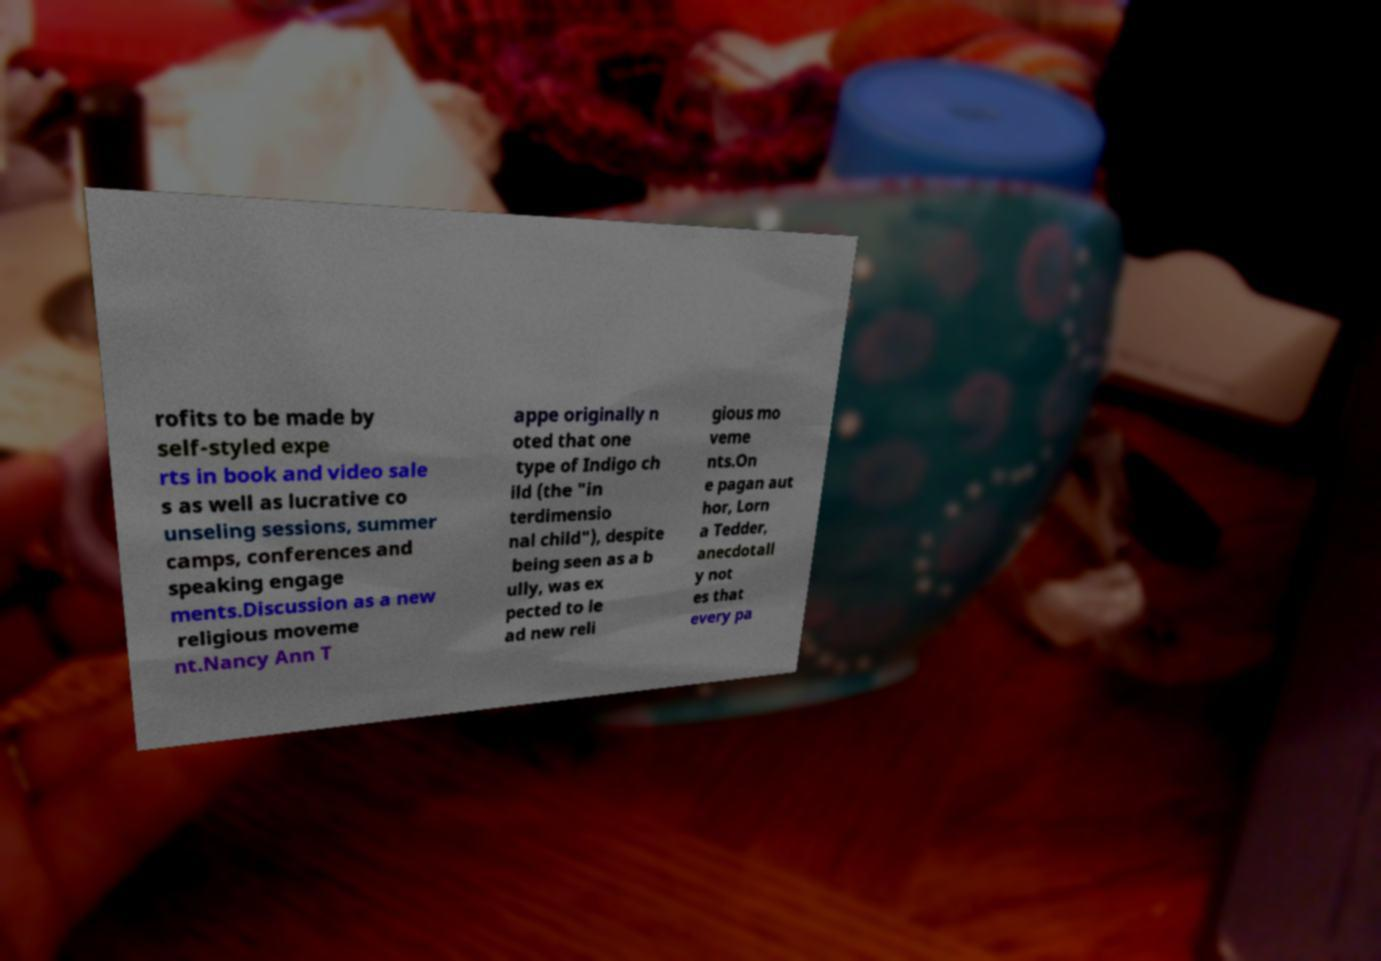Please identify and transcribe the text found in this image. rofits to be made by self-styled expe rts in book and video sale s as well as lucrative co unseling sessions, summer camps, conferences and speaking engage ments.Discussion as a new religious moveme nt.Nancy Ann T appe originally n oted that one type of Indigo ch ild (the "in terdimensio nal child"), despite being seen as a b ully, was ex pected to le ad new reli gious mo veme nts.On e pagan aut hor, Lorn a Tedder, anecdotall y not es that every pa 